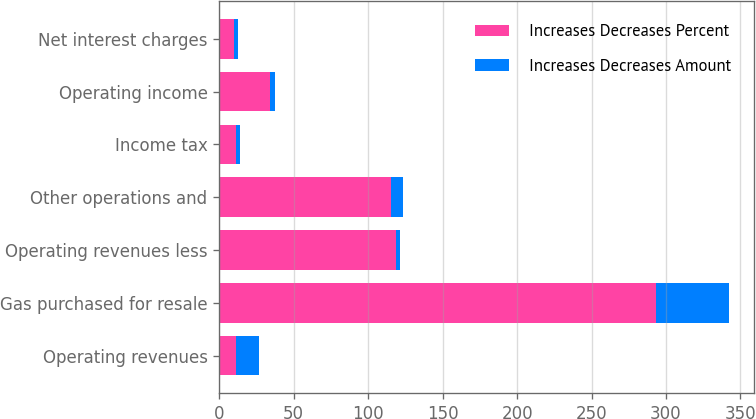Convert chart. <chart><loc_0><loc_0><loc_500><loc_500><stacked_bar_chart><ecel><fcel>Operating revenues<fcel>Gas purchased for resale<fcel>Operating revenues less<fcel>Other operations and<fcel>Income tax<fcel>Operating income<fcel>Net interest charges<nl><fcel>Increases Decreases Percent<fcel>11<fcel>293<fcel>119<fcel>115<fcel>11<fcel>34<fcel>10<nl><fcel>Increases Decreases Amount<fcel>15.4<fcel>49.2<fcel>2.7<fcel>8.7<fcel>2.7<fcel>3.2<fcel>2.3<nl></chart> 